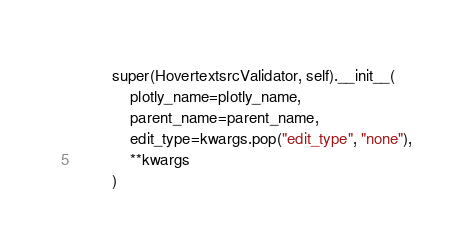<code> <loc_0><loc_0><loc_500><loc_500><_Python_>        super(HovertextsrcValidator, self).__init__(
            plotly_name=plotly_name,
            parent_name=parent_name,
            edit_type=kwargs.pop("edit_type", "none"),
            **kwargs
        )
</code> 